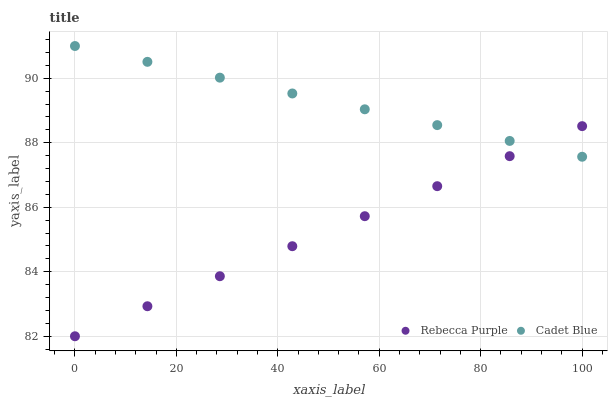Does Rebecca Purple have the minimum area under the curve?
Answer yes or no. Yes. Does Cadet Blue have the maximum area under the curve?
Answer yes or no. Yes. Does Rebecca Purple have the maximum area under the curve?
Answer yes or no. No. Is Cadet Blue the smoothest?
Answer yes or no. Yes. Is Rebecca Purple the roughest?
Answer yes or no. Yes. Is Rebecca Purple the smoothest?
Answer yes or no. No. Does Rebecca Purple have the lowest value?
Answer yes or no. Yes. Does Cadet Blue have the highest value?
Answer yes or no. Yes. Does Rebecca Purple have the highest value?
Answer yes or no. No. Does Rebecca Purple intersect Cadet Blue?
Answer yes or no. Yes. Is Rebecca Purple less than Cadet Blue?
Answer yes or no. No. Is Rebecca Purple greater than Cadet Blue?
Answer yes or no. No. 